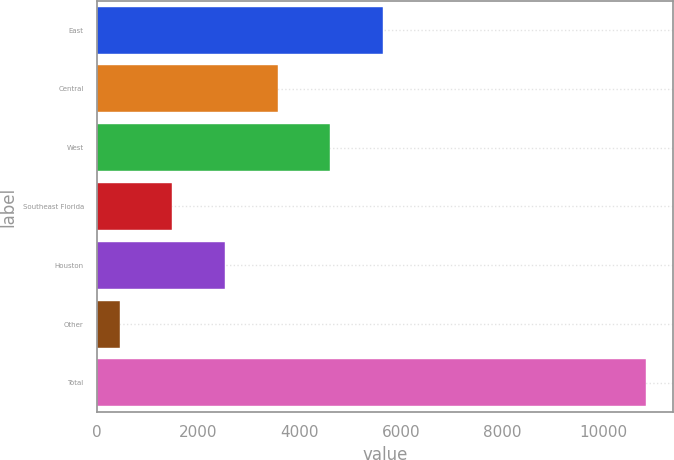Convert chart to OTSL. <chart><loc_0><loc_0><loc_500><loc_500><bar_chart><fcel>East<fcel>Central<fcel>West<fcel>Southeast Florida<fcel>Houston<fcel>Other<fcel>Total<nl><fcel>5646<fcel>3566.4<fcel>4606.2<fcel>1486.8<fcel>2526.6<fcel>447<fcel>10845<nl></chart> 